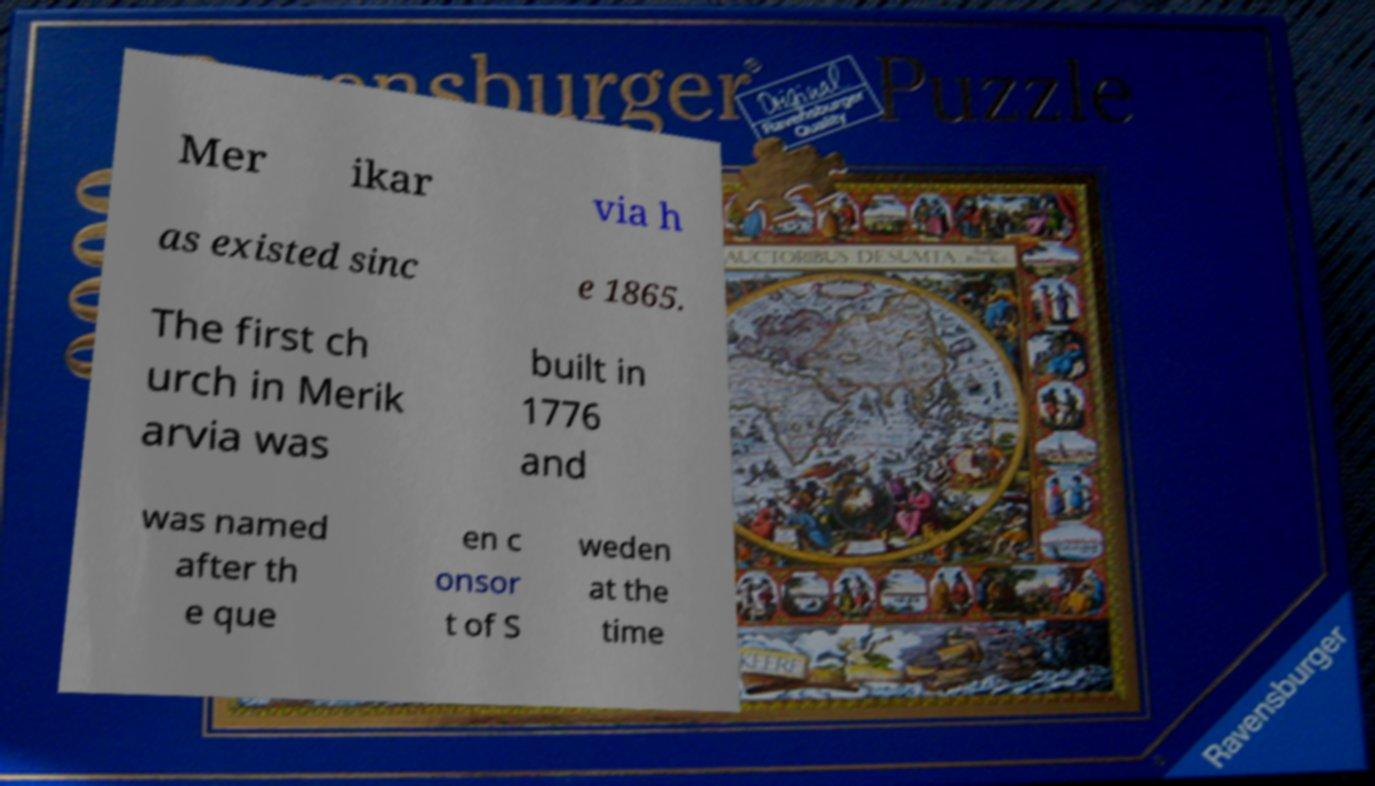There's text embedded in this image that I need extracted. Can you transcribe it verbatim? Mer ikar via h as existed sinc e 1865. The first ch urch in Merik arvia was built in 1776 and was named after th e que en c onsor t of S weden at the time 